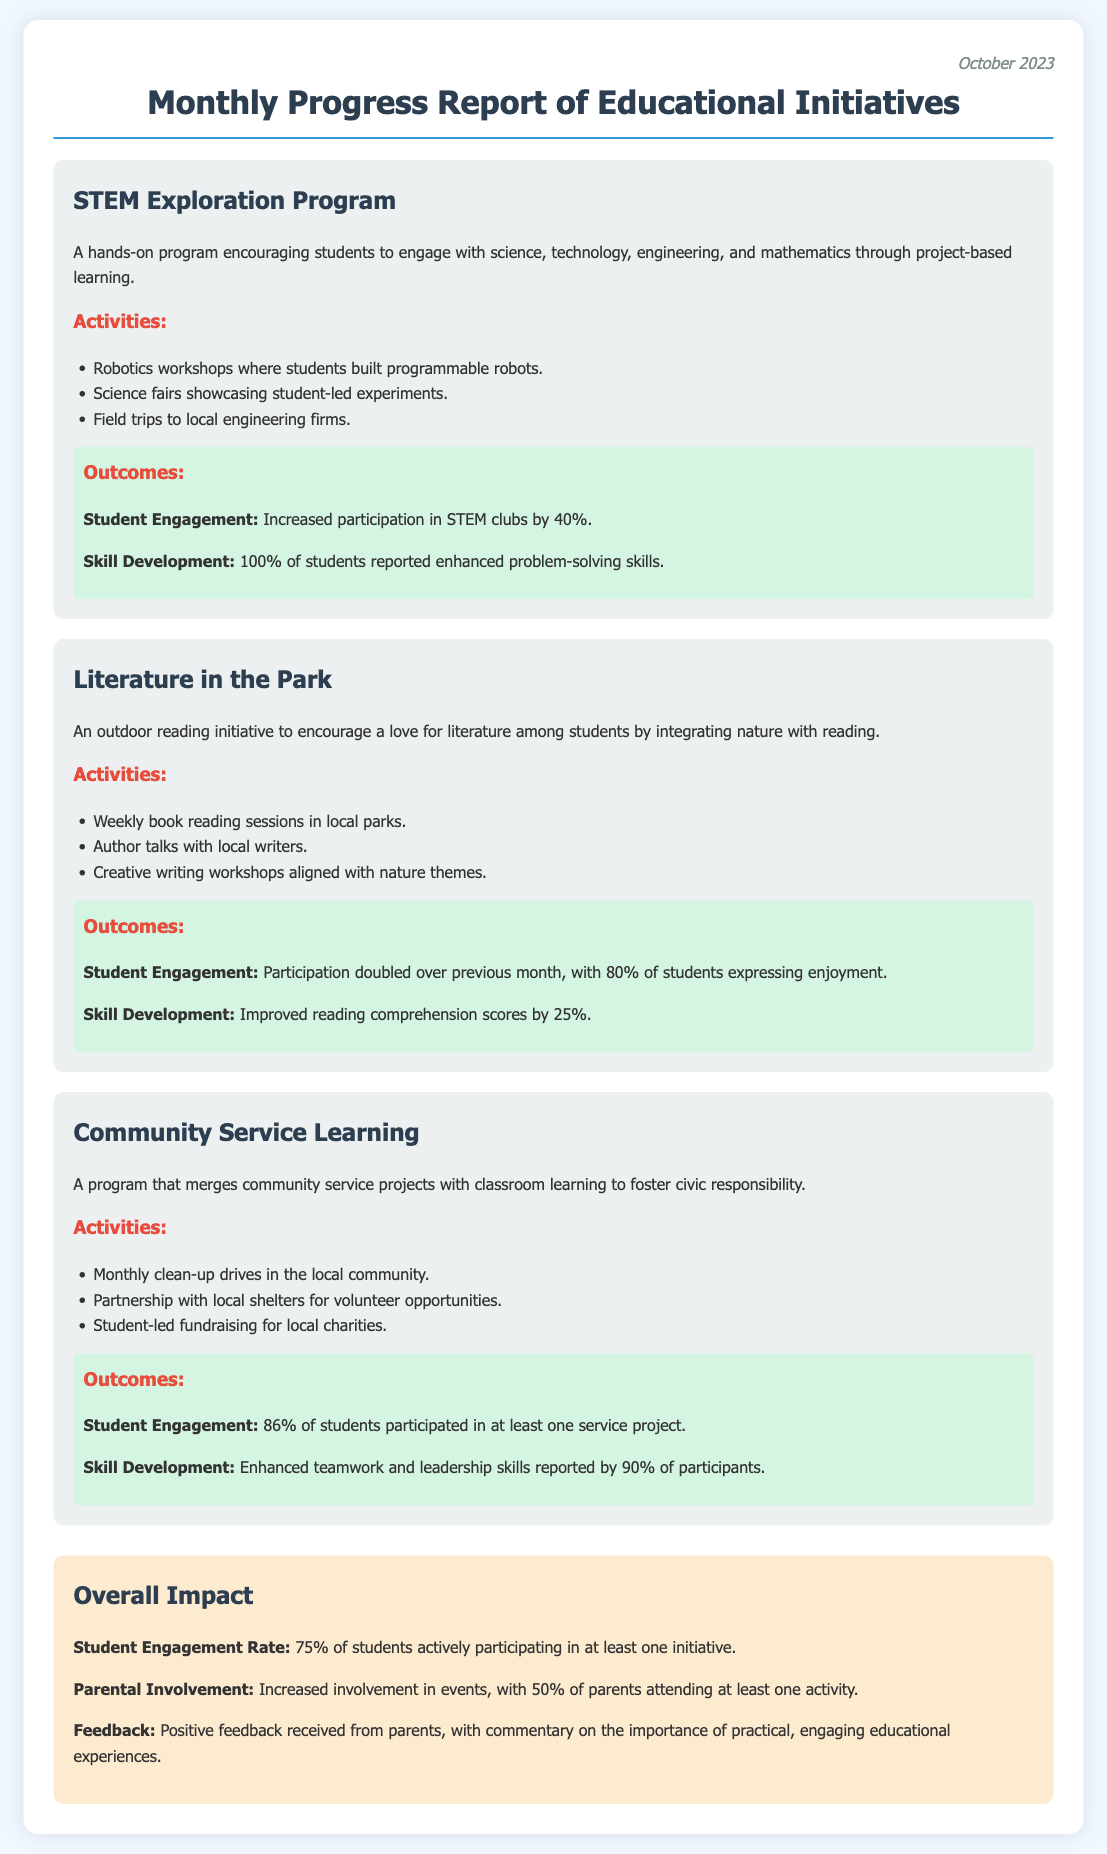What is the title of the report? The title is the main heading at the top of the document, summarizing its content.
Answer: Monthly Progress Report of Educational Initiatives What month is covered in this report? The report specifically mentions the current month in the header section.
Answer: October 2023 What activity is part of the STEM Exploration Program? Activities are listed under each initiative, including specific actions related to each program.
Answer: Robotics workshops What was the increase in participation for the Literature in the Park initiative? The outcome provides a specific percentage change regarding student participation from the previous month.
Answer: Doubled What percentage of students participated in at least one service project? This data is detailed in the outcomes for the Community Service Learning program.
Answer: 86% What is the overall student engagement rate? The overall impact section succinctly summarizes the percentage of students engaged in initiatives.
Answer: 75% What skill development percentage is reported for students in the STEM Exploration Program? The outcome section discusses the percentages related to skill enhancement in the different programs.
Answer: 100% What was the improvement in reading comprehension scores for Literature in the Park? The report indicates specific score improvements in student skills due to the program.
Answer: 25% What percentage of parents attended at least one activity? This detail about parental involvement is provided in the overall impact section.
Answer: 50% 